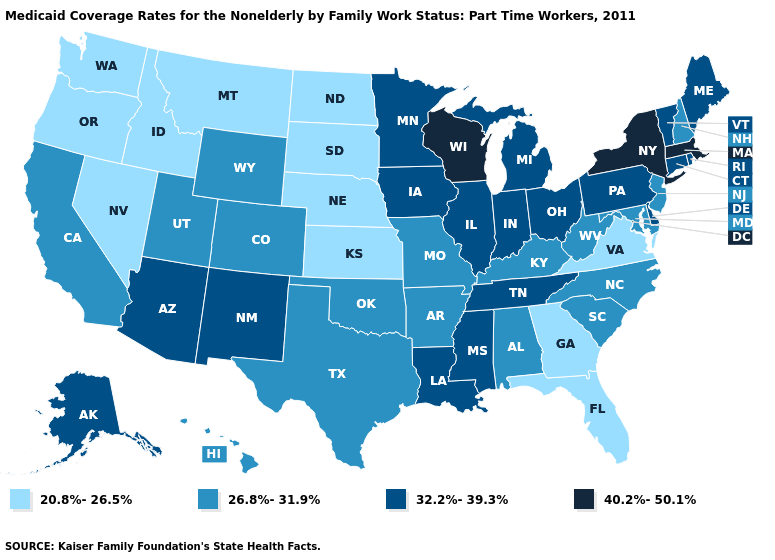Does the first symbol in the legend represent the smallest category?
Write a very short answer. Yes. Among the states that border Washington , which have the highest value?
Keep it brief. Idaho, Oregon. Does Georgia have the lowest value in the USA?
Write a very short answer. Yes. Name the states that have a value in the range 32.2%-39.3%?
Write a very short answer. Alaska, Arizona, Connecticut, Delaware, Illinois, Indiana, Iowa, Louisiana, Maine, Michigan, Minnesota, Mississippi, New Mexico, Ohio, Pennsylvania, Rhode Island, Tennessee, Vermont. Name the states that have a value in the range 32.2%-39.3%?
Keep it brief. Alaska, Arizona, Connecticut, Delaware, Illinois, Indiana, Iowa, Louisiana, Maine, Michigan, Minnesota, Mississippi, New Mexico, Ohio, Pennsylvania, Rhode Island, Tennessee, Vermont. What is the value of North Dakota?
Quick response, please. 20.8%-26.5%. Among the states that border Nevada , does Oregon have the lowest value?
Quick response, please. Yes. What is the highest value in the South ?
Concise answer only. 32.2%-39.3%. Does Wyoming have a lower value than Delaware?
Answer briefly. Yes. Among the states that border Louisiana , does Texas have the lowest value?
Keep it brief. Yes. How many symbols are there in the legend?
Quick response, please. 4. Name the states that have a value in the range 20.8%-26.5%?
Quick response, please. Florida, Georgia, Idaho, Kansas, Montana, Nebraska, Nevada, North Dakota, Oregon, South Dakota, Virginia, Washington. Does Washington have the same value as Montana?
Give a very brief answer. Yes. Does Montana have the same value as Maryland?
Give a very brief answer. No. Does the first symbol in the legend represent the smallest category?
Quick response, please. Yes. 